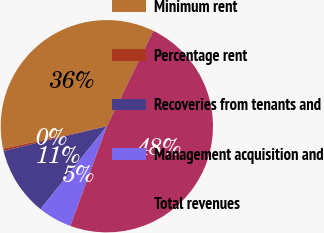Convert chart. <chart><loc_0><loc_0><loc_500><loc_500><pie_chart><fcel>Minimum rent<fcel>Percentage rent<fcel>Recoveries from tenants and<fcel>Management acquisition and<fcel>Total revenues<nl><fcel>35.62%<fcel>0.34%<fcel>10.53%<fcel>5.15%<fcel>48.36%<nl></chart> 